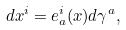Convert formula to latex. <formula><loc_0><loc_0><loc_500><loc_500>d x ^ { i } = e _ { a } ^ { i } ( x ) d \gamma ^ { a } ,</formula> 